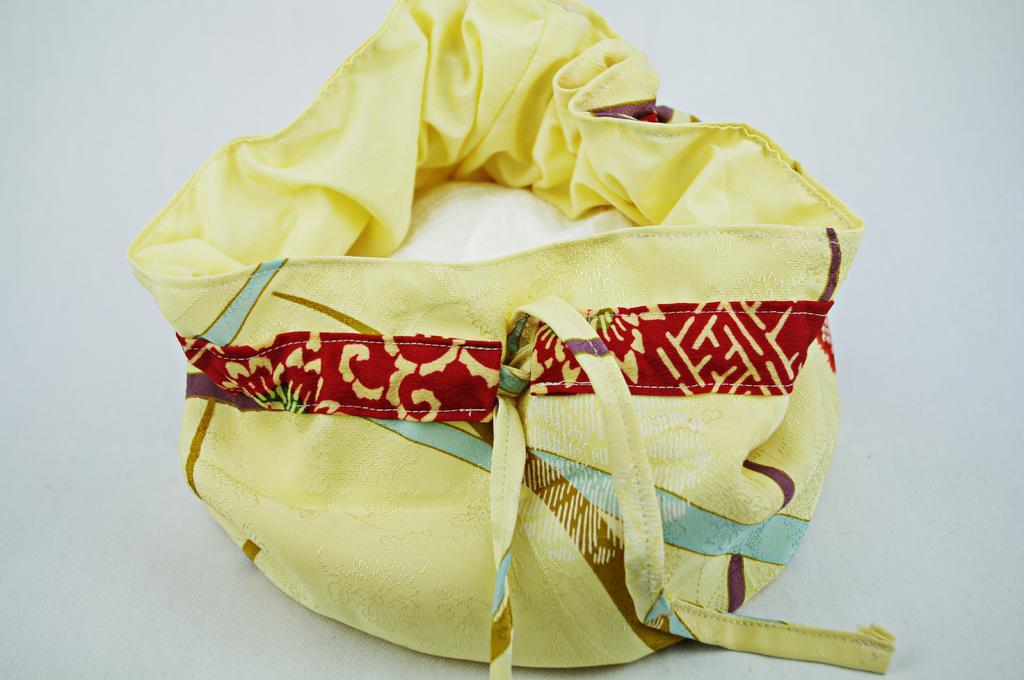How would you summarize this image in a sentence or two? In this image I can see a yellow color of bag. 